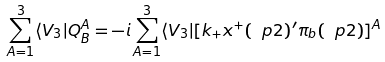Convert formula to latex. <formula><loc_0><loc_0><loc_500><loc_500>\sum _ { A = 1 } ^ { 3 } \langle V _ { 3 } | Q _ { B } ^ { A } = - i \sum _ { A = 1 } ^ { 3 } \langle V _ { 3 } | [ k _ { + } x ^ { + } ( \ p 2 ) ^ { \prime } \pi _ { b } ( \ p 2 ) ] ^ { A }</formula> 